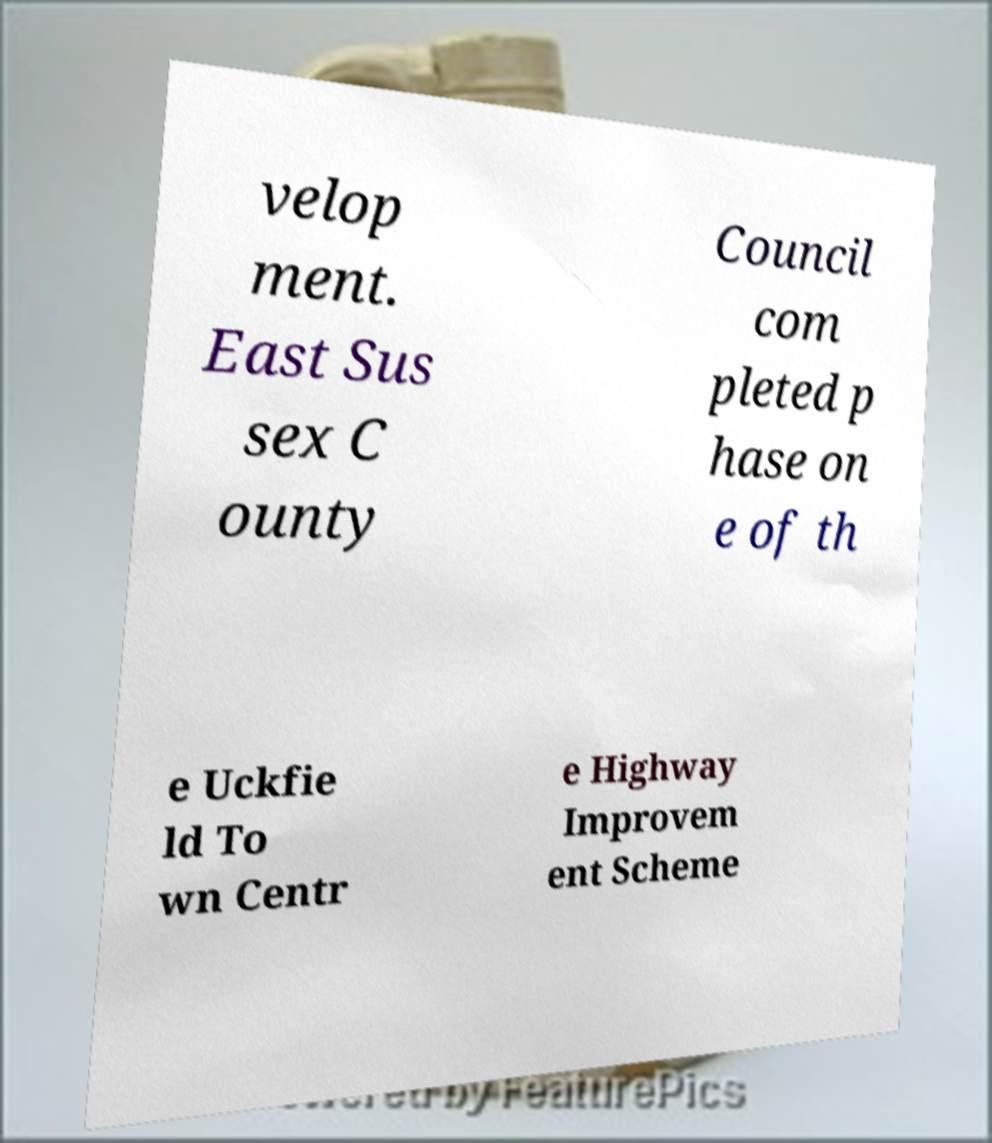I need the written content from this picture converted into text. Can you do that? velop ment. East Sus sex C ounty Council com pleted p hase on e of th e Uckfie ld To wn Centr e Highway Improvem ent Scheme 